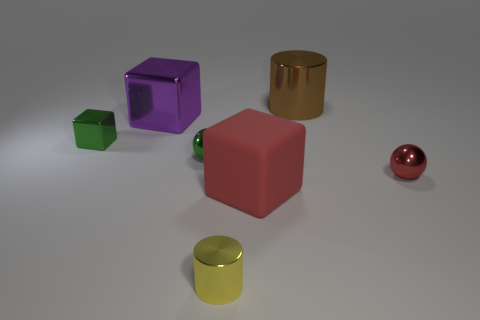How are the objects organized in the image? The objects in the image are spaced out on a flat surface with no apparent pattern to their arrangement, each distinct in color and shape, promoting a sense of diversity yet orderliness. 